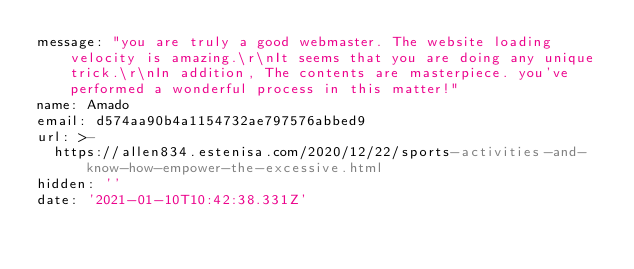<code> <loc_0><loc_0><loc_500><loc_500><_YAML_>message: "you are truly a good webmaster. The website loading velocity is amazing.\r\nIt seems that you are doing any unique trick.\r\nIn addition, The contents are masterpiece. you've performed a wonderful process in this matter!"
name: Amado
email: d574aa90b4a1154732ae797576abbed9
url: >-
  https://allen834.estenisa.com/2020/12/22/sports-activities-and-know-how-empower-the-excessive.html
hidden: ''
date: '2021-01-10T10:42:38.331Z'
</code> 